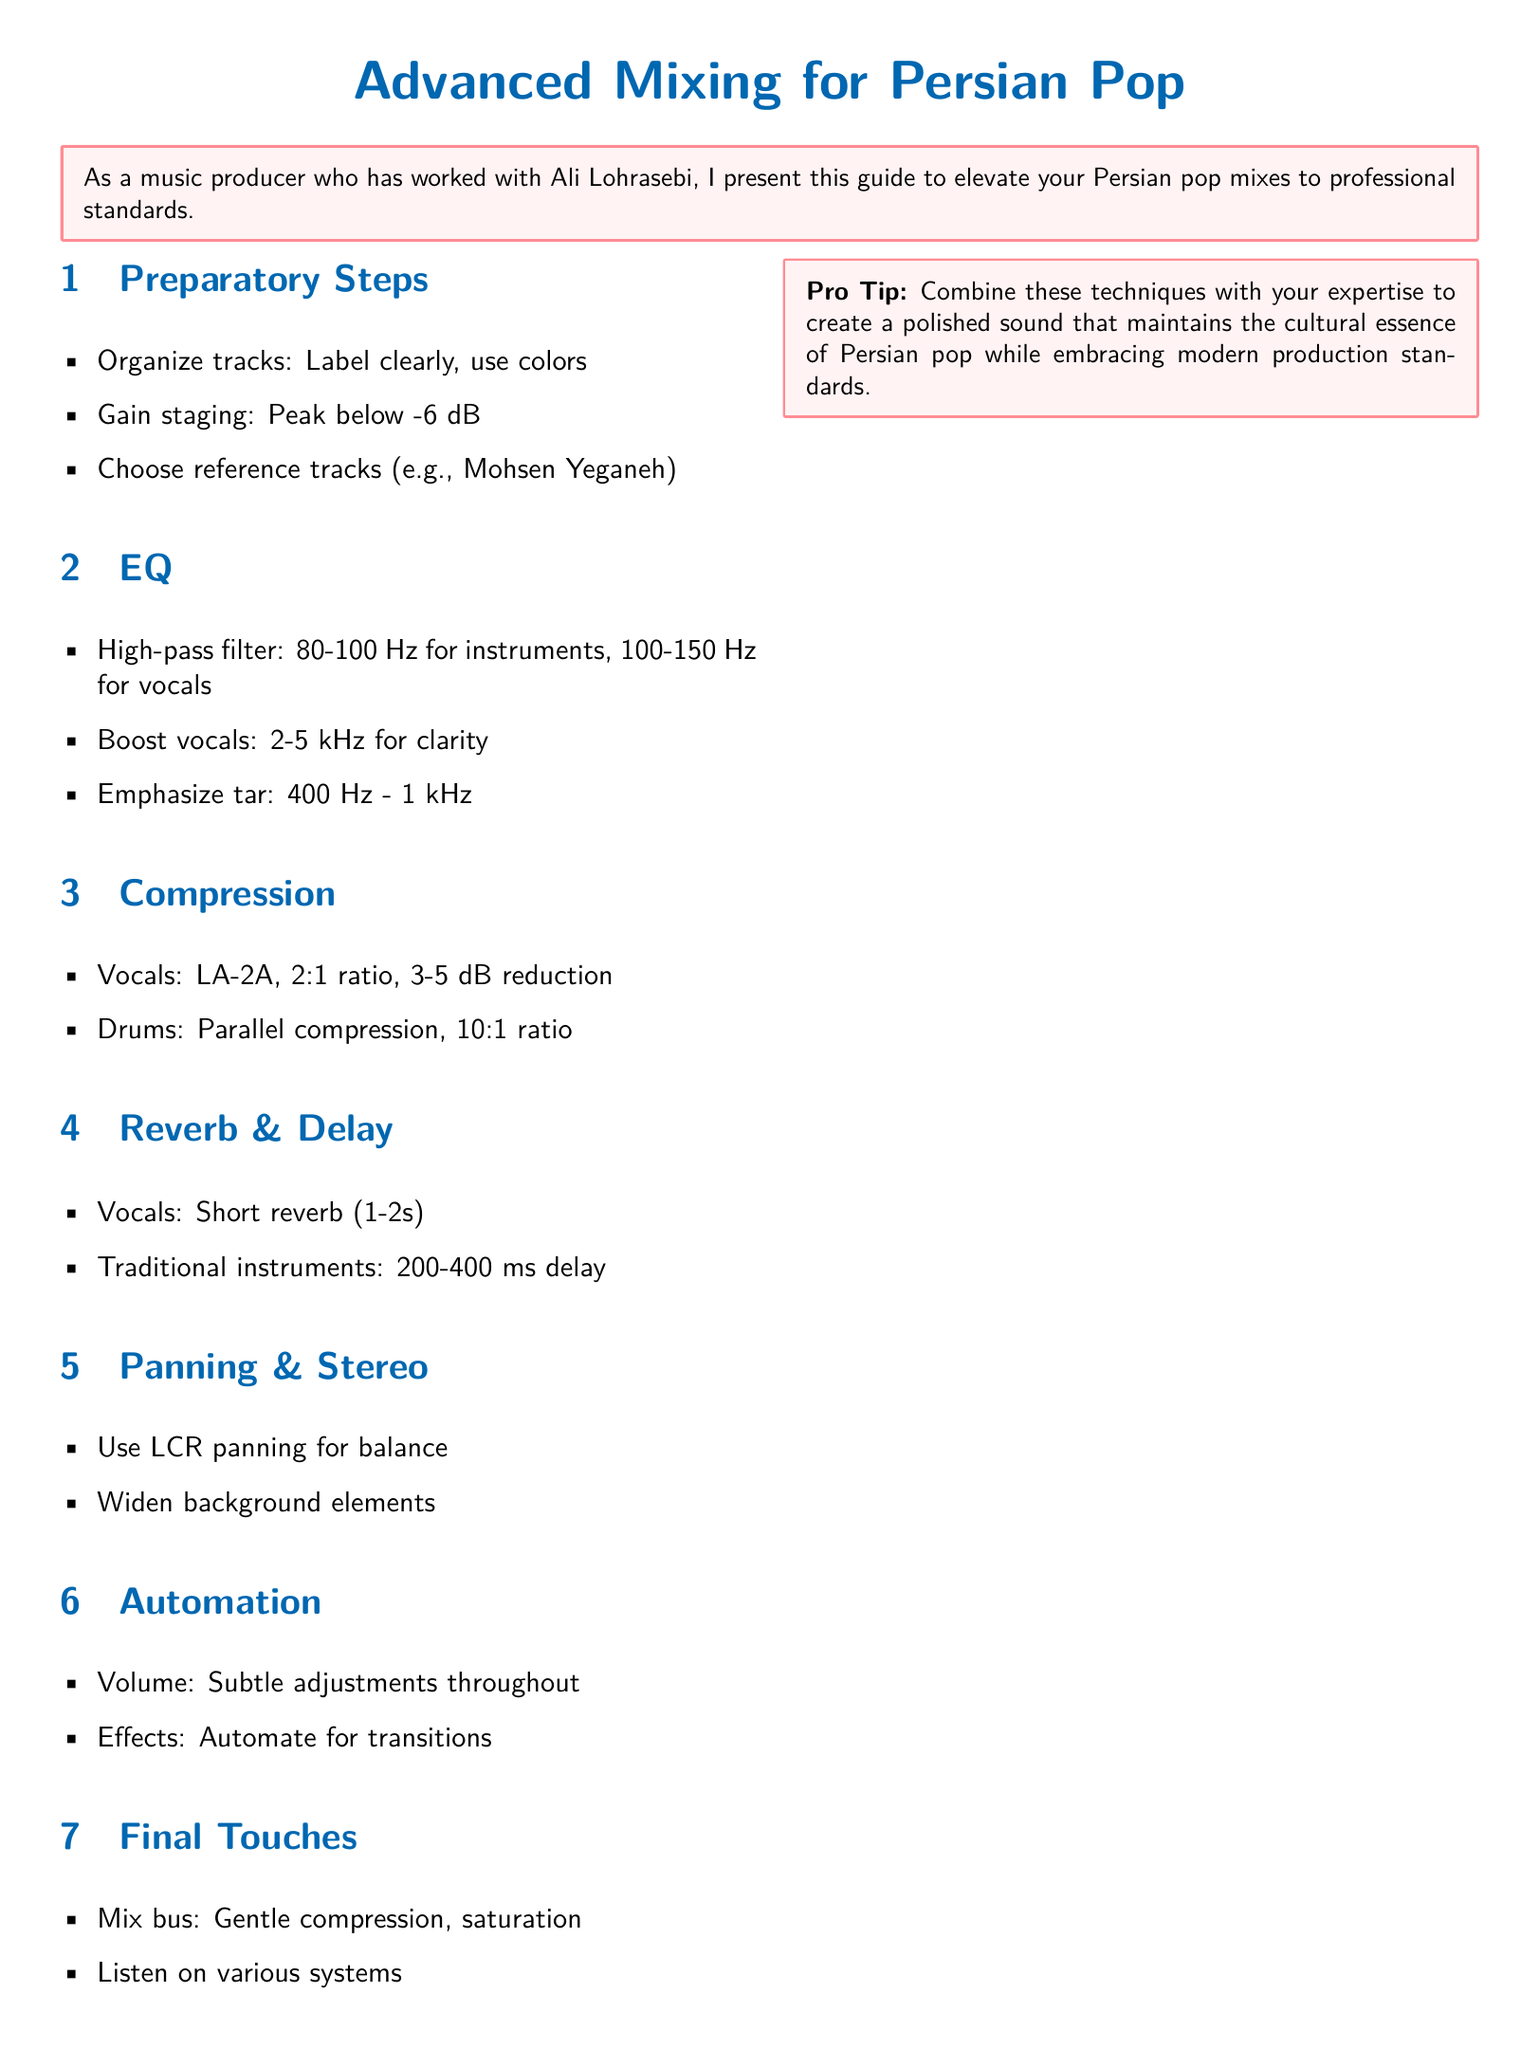What should tracks be before mixing? The guide suggests that tracks should be clearly labeled and color-coded for organization.
Answer: Clearly labeled, color-coded What is the peak level for gain staging? The document states the peak level for gain staging should be below -6 dB.
Answer: Below -6 dB Which compressor is recommended for vocals? The guide mentions the LA-2A compressor with a 2:1 ratio for vocals.
Answer: LA-2A What delay time is suggested for traditional instruments? The recommended delay time for traditional instruments is 200-400 ms.
Answer: 200-400 ms What is a pro tip mentioned in the guide? The pro tip advises to combine the techniques with expertise to create a polished sound.
Answer: Combine techniques with expertise What frequency range should be emphasized for the tar instrument? The guide emphasizes the frequency range of 400 Hz - 1 kHz for the tar.
Answer: 400 Hz - 1 kHz How long should the reverb be for vocals? The document suggests a short reverb time of 1-2 seconds for vocals.
Answer: 1-2 seconds What panning technique is recommended for balance? The guide recommends using LCR panning for balance.
Answer: LCR panning What type of adjustments are suggested for automation? The document suggests subtle volume adjustments throughout for automation.
Answer: Subtle volume adjustments 